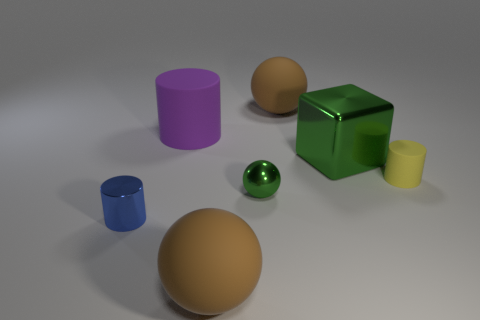Subtract all rubber balls. How many balls are left? 1 Subtract all blue blocks. How many brown balls are left? 2 Add 2 blue cylinders. How many objects exist? 9 Subtract all blue cylinders. How many cylinders are left? 2 Subtract all blocks. How many objects are left? 6 Add 1 large brown rubber objects. How many large brown rubber objects exist? 3 Subtract 0 yellow balls. How many objects are left? 7 Subtract all brown cylinders. Subtract all green balls. How many cylinders are left? 3 Subtract all small green balls. Subtract all brown rubber spheres. How many objects are left? 4 Add 6 yellow cylinders. How many yellow cylinders are left? 7 